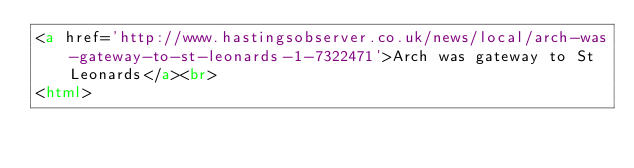Convert code to text. <code><loc_0><loc_0><loc_500><loc_500><_HTML_><a href='http://www.hastingsobserver.co.uk/news/local/arch-was-gateway-to-st-leonards-1-7322471'>Arch was gateway to St Leonards</a><br>
<html></code> 